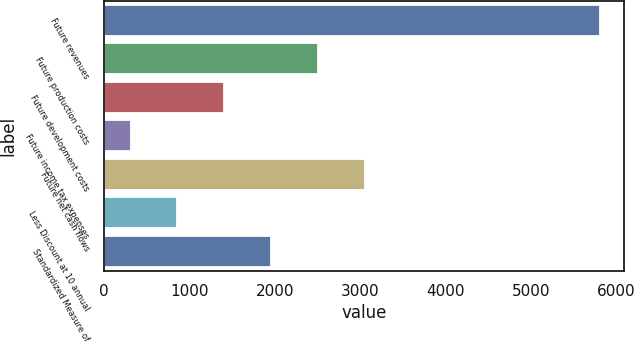<chart> <loc_0><loc_0><loc_500><loc_500><bar_chart><fcel>Future revenues<fcel>Future production costs<fcel>Future development costs<fcel>Future income tax expenses<fcel>Future net cash flows<fcel>Less Discount at 10 annual<fcel>Standardized Measure of<nl><fcel>5800<fcel>2507.8<fcel>1410.4<fcel>313<fcel>3056.5<fcel>861.7<fcel>1959.1<nl></chart> 